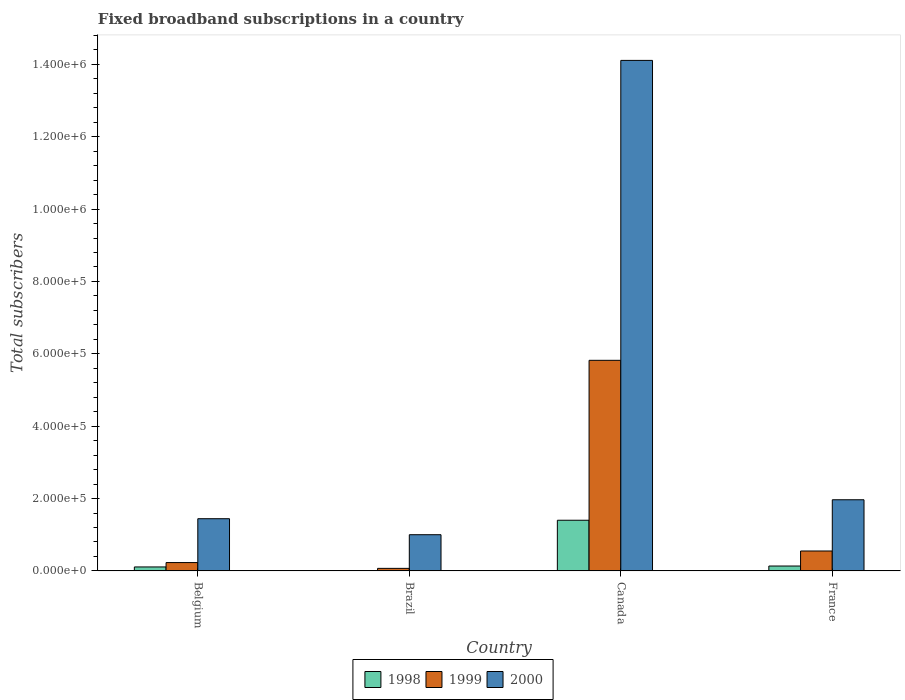How many different coloured bars are there?
Make the answer very short. 3. How many groups of bars are there?
Provide a succinct answer. 4. Are the number of bars on each tick of the X-axis equal?
Provide a short and direct response. Yes. What is the number of broadband subscriptions in 1999 in France?
Provide a succinct answer. 5.50e+04. Across all countries, what is the maximum number of broadband subscriptions in 1999?
Make the answer very short. 5.82e+05. In which country was the number of broadband subscriptions in 1998 maximum?
Offer a very short reply. Canada. What is the total number of broadband subscriptions in 2000 in the graph?
Your response must be concise. 1.85e+06. What is the difference between the number of broadband subscriptions in 1998 in Belgium and that in Brazil?
Your response must be concise. 9924. What is the difference between the number of broadband subscriptions in 1999 in France and the number of broadband subscriptions in 2000 in Brazil?
Provide a short and direct response. -4.50e+04. What is the average number of broadband subscriptions in 1999 per country?
Provide a succinct answer. 1.67e+05. What is the difference between the number of broadband subscriptions of/in 1998 and number of broadband subscriptions of/in 2000 in Canada?
Provide a succinct answer. -1.27e+06. In how many countries, is the number of broadband subscriptions in 2000 greater than 640000?
Ensure brevity in your answer.  1. What is the ratio of the number of broadband subscriptions in 1999 in Belgium to that in Brazil?
Your answer should be compact. 3.29. Is the number of broadband subscriptions in 2000 in Canada less than that in France?
Give a very brief answer. No. What is the difference between the highest and the second highest number of broadband subscriptions in 1998?
Your answer should be very brief. 1.29e+05. What is the difference between the highest and the lowest number of broadband subscriptions in 1998?
Keep it short and to the point. 1.39e+05. In how many countries, is the number of broadband subscriptions in 1999 greater than the average number of broadband subscriptions in 1999 taken over all countries?
Offer a very short reply. 1. What does the 2nd bar from the left in Brazil represents?
Your response must be concise. 1999. What does the 2nd bar from the right in Canada represents?
Offer a very short reply. 1999. Is it the case that in every country, the sum of the number of broadband subscriptions in 2000 and number of broadband subscriptions in 1998 is greater than the number of broadband subscriptions in 1999?
Offer a terse response. Yes. What is the difference between two consecutive major ticks on the Y-axis?
Keep it short and to the point. 2.00e+05. Are the values on the major ticks of Y-axis written in scientific E-notation?
Keep it short and to the point. Yes. Does the graph contain any zero values?
Provide a succinct answer. No. Does the graph contain grids?
Provide a short and direct response. No. What is the title of the graph?
Ensure brevity in your answer.  Fixed broadband subscriptions in a country. Does "1986" appear as one of the legend labels in the graph?
Provide a succinct answer. No. What is the label or title of the Y-axis?
Provide a short and direct response. Total subscribers. What is the Total subscribers in 1998 in Belgium?
Offer a terse response. 1.09e+04. What is the Total subscribers of 1999 in Belgium?
Ensure brevity in your answer.  2.30e+04. What is the Total subscribers of 2000 in Belgium?
Offer a very short reply. 1.44e+05. What is the Total subscribers of 1999 in Brazil?
Provide a short and direct response. 7000. What is the Total subscribers of 1998 in Canada?
Provide a succinct answer. 1.40e+05. What is the Total subscribers of 1999 in Canada?
Your response must be concise. 5.82e+05. What is the Total subscribers of 2000 in Canada?
Provide a succinct answer. 1.41e+06. What is the Total subscribers of 1998 in France?
Offer a very short reply. 1.35e+04. What is the Total subscribers of 1999 in France?
Your response must be concise. 5.50e+04. What is the Total subscribers in 2000 in France?
Offer a very short reply. 1.97e+05. Across all countries, what is the maximum Total subscribers of 1999?
Ensure brevity in your answer.  5.82e+05. Across all countries, what is the maximum Total subscribers of 2000?
Provide a short and direct response. 1.41e+06. Across all countries, what is the minimum Total subscribers of 1998?
Provide a short and direct response. 1000. Across all countries, what is the minimum Total subscribers in 1999?
Offer a terse response. 7000. Across all countries, what is the minimum Total subscribers of 2000?
Keep it short and to the point. 1.00e+05. What is the total Total subscribers of 1998 in the graph?
Provide a succinct answer. 1.65e+05. What is the total Total subscribers of 1999 in the graph?
Provide a short and direct response. 6.67e+05. What is the total Total subscribers in 2000 in the graph?
Offer a terse response. 1.85e+06. What is the difference between the Total subscribers in 1998 in Belgium and that in Brazil?
Provide a succinct answer. 9924. What is the difference between the Total subscribers of 1999 in Belgium and that in Brazil?
Your response must be concise. 1.60e+04. What is the difference between the Total subscribers in 2000 in Belgium and that in Brazil?
Ensure brevity in your answer.  4.42e+04. What is the difference between the Total subscribers in 1998 in Belgium and that in Canada?
Give a very brief answer. -1.29e+05. What is the difference between the Total subscribers in 1999 in Belgium and that in Canada?
Ensure brevity in your answer.  -5.59e+05. What is the difference between the Total subscribers of 2000 in Belgium and that in Canada?
Your answer should be compact. -1.27e+06. What is the difference between the Total subscribers of 1998 in Belgium and that in France?
Offer a terse response. -2540. What is the difference between the Total subscribers in 1999 in Belgium and that in France?
Give a very brief answer. -3.20e+04. What is the difference between the Total subscribers of 2000 in Belgium and that in France?
Make the answer very short. -5.24e+04. What is the difference between the Total subscribers of 1998 in Brazil and that in Canada?
Your answer should be compact. -1.39e+05. What is the difference between the Total subscribers of 1999 in Brazil and that in Canada?
Ensure brevity in your answer.  -5.75e+05. What is the difference between the Total subscribers in 2000 in Brazil and that in Canada?
Give a very brief answer. -1.31e+06. What is the difference between the Total subscribers of 1998 in Brazil and that in France?
Provide a short and direct response. -1.25e+04. What is the difference between the Total subscribers in 1999 in Brazil and that in France?
Keep it short and to the point. -4.80e+04. What is the difference between the Total subscribers in 2000 in Brazil and that in France?
Your response must be concise. -9.66e+04. What is the difference between the Total subscribers of 1998 in Canada and that in France?
Your response must be concise. 1.27e+05. What is the difference between the Total subscribers in 1999 in Canada and that in France?
Your answer should be very brief. 5.27e+05. What is the difference between the Total subscribers of 2000 in Canada and that in France?
Your answer should be compact. 1.21e+06. What is the difference between the Total subscribers in 1998 in Belgium and the Total subscribers in 1999 in Brazil?
Give a very brief answer. 3924. What is the difference between the Total subscribers of 1998 in Belgium and the Total subscribers of 2000 in Brazil?
Your response must be concise. -8.91e+04. What is the difference between the Total subscribers in 1999 in Belgium and the Total subscribers in 2000 in Brazil?
Give a very brief answer. -7.70e+04. What is the difference between the Total subscribers in 1998 in Belgium and the Total subscribers in 1999 in Canada?
Keep it short and to the point. -5.71e+05. What is the difference between the Total subscribers in 1998 in Belgium and the Total subscribers in 2000 in Canada?
Offer a very short reply. -1.40e+06. What is the difference between the Total subscribers in 1999 in Belgium and the Total subscribers in 2000 in Canada?
Provide a short and direct response. -1.39e+06. What is the difference between the Total subscribers of 1998 in Belgium and the Total subscribers of 1999 in France?
Offer a terse response. -4.41e+04. What is the difference between the Total subscribers of 1998 in Belgium and the Total subscribers of 2000 in France?
Your answer should be very brief. -1.86e+05. What is the difference between the Total subscribers of 1999 in Belgium and the Total subscribers of 2000 in France?
Offer a terse response. -1.74e+05. What is the difference between the Total subscribers in 1998 in Brazil and the Total subscribers in 1999 in Canada?
Ensure brevity in your answer.  -5.81e+05. What is the difference between the Total subscribers in 1998 in Brazil and the Total subscribers in 2000 in Canada?
Provide a short and direct response. -1.41e+06. What is the difference between the Total subscribers in 1999 in Brazil and the Total subscribers in 2000 in Canada?
Offer a very short reply. -1.40e+06. What is the difference between the Total subscribers in 1998 in Brazil and the Total subscribers in 1999 in France?
Provide a succinct answer. -5.40e+04. What is the difference between the Total subscribers of 1998 in Brazil and the Total subscribers of 2000 in France?
Ensure brevity in your answer.  -1.96e+05. What is the difference between the Total subscribers of 1999 in Brazil and the Total subscribers of 2000 in France?
Offer a terse response. -1.90e+05. What is the difference between the Total subscribers of 1998 in Canada and the Total subscribers of 1999 in France?
Your response must be concise. 8.50e+04. What is the difference between the Total subscribers of 1998 in Canada and the Total subscribers of 2000 in France?
Ensure brevity in your answer.  -5.66e+04. What is the difference between the Total subscribers in 1999 in Canada and the Total subscribers in 2000 in France?
Make the answer very short. 3.85e+05. What is the average Total subscribers of 1998 per country?
Offer a terse response. 4.13e+04. What is the average Total subscribers of 1999 per country?
Your response must be concise. 1.67e+05. What is the average Total subscribers of 2000 per country?
Make the answer very short. 4.63e+05. What is the difference between the Total subscribers of 1998 and Total subscribers of 1999 in Belgium?
Ensure brevity in your answer.  -1.21e+04. What is the difference between the Total subscribers in 1998 and Total subscribers in 2000 in Belgium?
Ensure brevity in your answer.  -1.33e+05. What is the difference between the Total subscribers in 1999 and Total subscribers in 2000 in Belgium?
Your response must be concise. -1.21e+05. What is the difference between the Total subscribers in 1998 and Total subscribers in 1999 in Brazil?
Make the answer very short. -6000. What is the difference between the Total subscribers of 1998 and Total subscribers of 2000 in Brazil?
Give a very brief answer. -9.90e+04. What is the difference between the Total subscribers of 1999 and Total subscribers of 2000 in Brazil?
Offer a terse response. -9.30e+04. What is the difference between the Total subscribers in 1998 and Total subscribers in 1999 in Canada?
Offer a terse response. -4.42e+05. What is the difference between the Total subscribers in 1998 and Total subscribers in 2000 in Canada?
Your answer should be compact. -1.27e+06. What is the difference between the Total subscribers in 1999 and Total subscribers in 2000 in Canada?
Keep it short and to the point. -8.29e+05. What is the difference between the Total subscribers of 1998 and Total subscribers of 1999 in France?
Provide a succinct answer. -4.15e+04. What is the difference between the Total subscribers in 1998 and Total subscribers in 2000 in France?
Provide a short and direct response. -1.83e+05. What is the difference between the Total subscribers of 1999 and Total subscribers of 2000 in France?
Offer a terse response. -1.42e+05. What is the ratio of the Total subscribers of 1998 in Belgium to that in Brazil?
Keep it short and to the point. 10.92. What is the ratio of the Total subscribers in 1999 in Belgium to that in Brazil?
Ensure brevity in your answer.  3.29. What is the ratio of the Total subscribers of 2000 in Belgium to that in Brazil?
Keep it short and to the point. 1.44. What is the ratio of the Total subscribers in 1998 in Belgium to that in Canada?
Your answer should be compact. 0.08. What is the ratio of the Total subscribers in 1999 in Belgium to that in Canada?
Your answer should be very brief. 0.04. What is the ratio of the Total subscribers in 2000 in Belgium to that in Canada?
Keep it short and to the point. 0.1. What is the ratio of the Total subscribers of 1998 in Belgium to that in France?
Your response must be concise. 0.81. What is the ratio of the Total subscribers in 1999 in Belgium to that in France?
Your response must be concise. 0.42. What is the ratio of the Total subscribers of 2000 in Belgium to that in France?
Your answer should be very brief. 0.73. What is the ratio of the Total subscribers in 1998 in Brazil to that in Canada?
Ensure brevity in your answer.  0.01. What is the ratio of the Total subscribers of 1999 in Brazil to that in Canada?
Make the answer very short. 0.01. What is the ratio of the Total subscribers of 2000 in Brazil to that in Canada?
Offer a terse response. 0.07. What is the ratio of the Total subscribers of 1998 in Brazil to that in France?
Give a very brief answer. 0.07. What is the ratio of the Total subscribers in 1999 in Brazil to that in France?
Ensure brevity in your answer.  0.13. What is the ratio of the Total subscribers of 2000 in Brazil to that in France?
Offer a very short reply. 0.51. What is the ratio of the Total subscribers in 1998 in Canada to that in France?
Keep it short and to the point. 10.4. What is the ratio of the Total subscribers in 1999 in Canada to that in France?
Provide a short and direct response. 10.58. What is the ratio of the Total subscribers of 2000 in Canada to that in France?
Give a very brief answer. 7.18. What is the difference between the highest and the second highest Total subscribers in 1998?
Your response must be concise. 1.27e+05. What is the difference between the highest and the second highest Total subscribers in 1999?
Offer a very short reply. 5.27e+05. What is the difference between the highest and the second highest Total subscribers of 2000?
Provide a short and direct response. 1.21e+06. What is the difference between the highest and the lowest Total subscribers of 1998?
Give a very brief answer. 1.39e+05. What is the difference between the highest and the lowest Total subscribers of 1999?
Keep it short and to the point. 5.75e+05. What is the difference between the highest and the lowest Total subscribers in 2000?
Your response must be concise. 1.31e+06. 